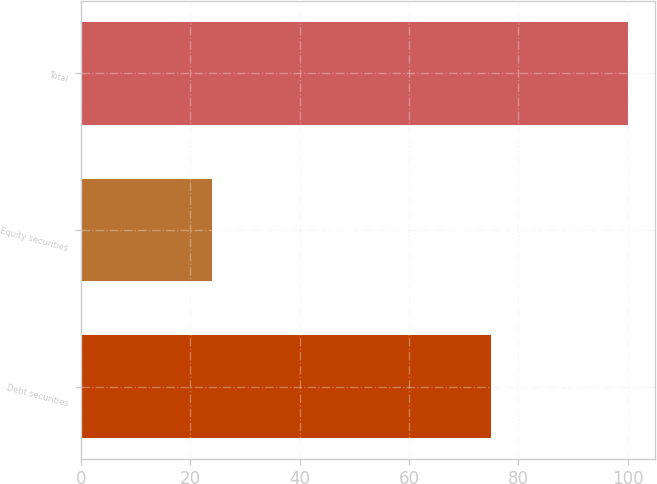Convert chart to OTSL. <chart><loc_0><loc_0><loc_500><loc_500><bar_chart><fcel>Debt securities<fcel>Equity securities<fcel>Total<nl><fcel>75<fcel>24<fcel>100<nl></chart> 